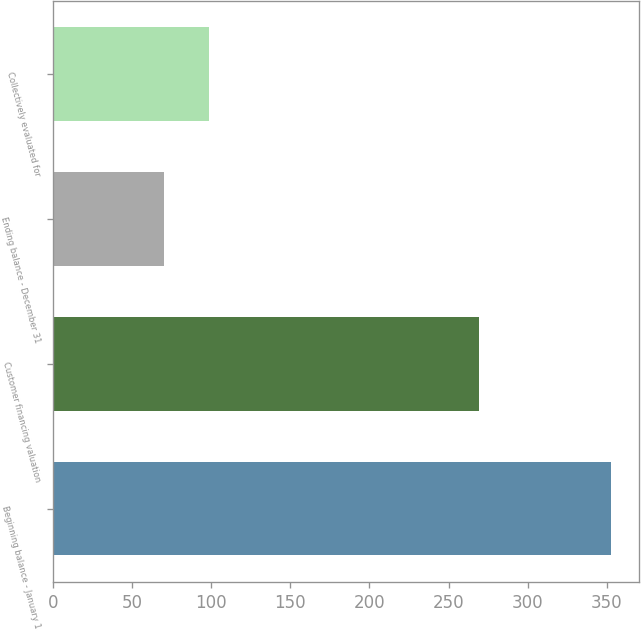Convert chart. <chart><loc_0><loc_0><loc_500><loc_500><bar_chart><fcel>Beginning balance - January 1<fcel>Customer financing valuation<fcel>Ending balance - December 31<fcel>Collectively evaluated for<nl><fcel>353<fcel>269<fcel>70<fcel>98.3<nl></chart> 